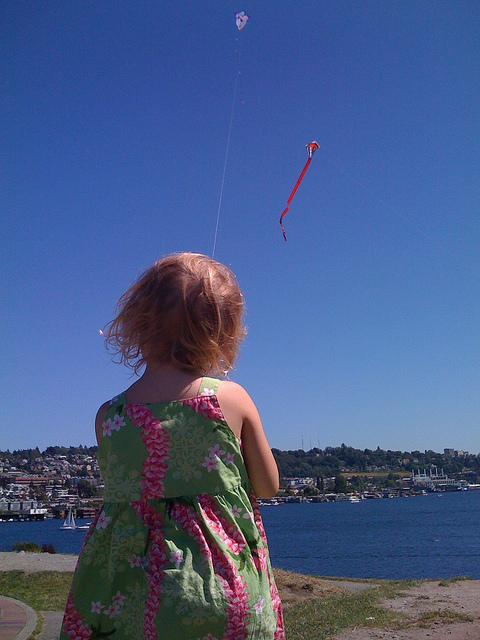<image>What type of fan is she holding? She is not holding a fan in the image. However, it can be seen as a kite. What type of fan is she holding? I don't know what type of fan she is holding. It can be seen 'kite' or 'none'. 